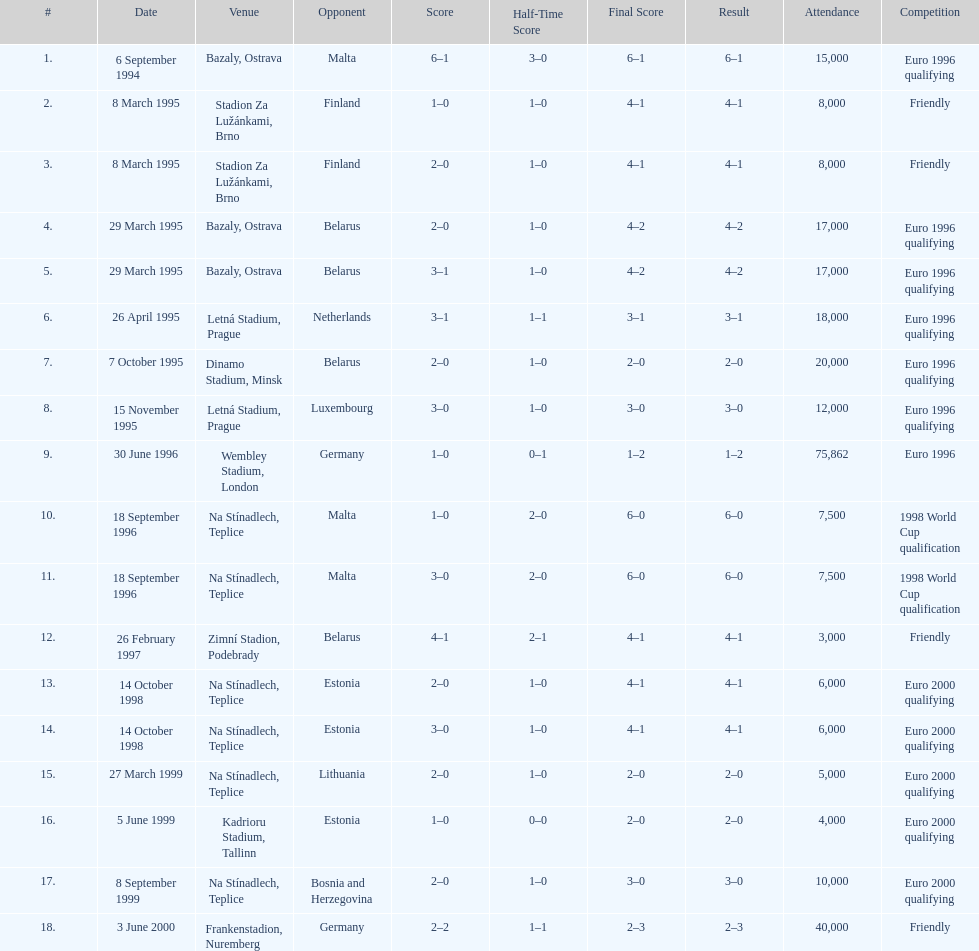How many euro 2000 qualifying competitions are listed? 4. 